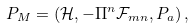Convert formula to latex. <formula><loc_0><loc_0><loc_500><loc_500>P _ { M } = \left ( \mathcal { H } , - \Pi ^ { n } \mathcal { F } _ { m n } , P _ { a } \right ) ,</formula> 